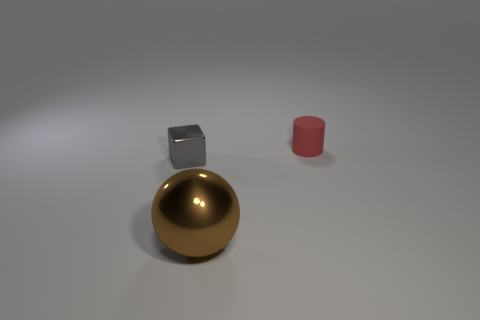Add 1 red matte things. How many objects exist? 4 Subtract all balls. How many objects are left? 2 Subtract all gray cylinders. How many green balls are left? 0 Subtract all large yellow things. Subtract all tiny red cylinders. How many objects are left? 2 Add 3 red matte things. How many red matte things are left? 4 Add 1 small gray metallic cubes. How many small gray metallic cubes exist? 2 Subtract 0 blue balls. How many objects are left? 3 Subtract 1 blocks. How many blocks are left? 0 Subtract all blue blocks. Subtract all green cylinders. How many blocks are left? 1 